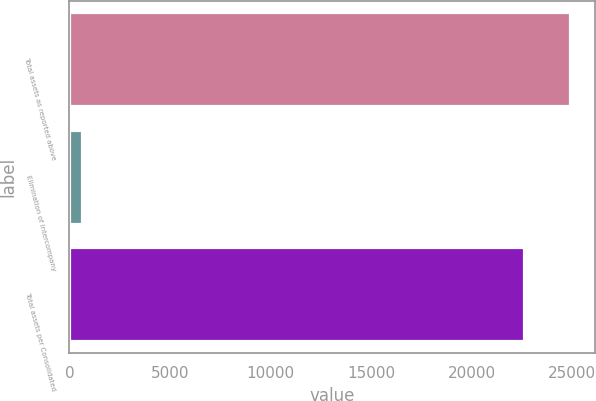<chart> <loc_0><loc_0><loc_500><loc_500><bar_chart><fcel>Total assets as reported above<fcel>Elimination of intercompany<fcel>Total assets per Consolidated<nl><fcel>24863.3<fcel>612<fcel>22603<nl></chart> 